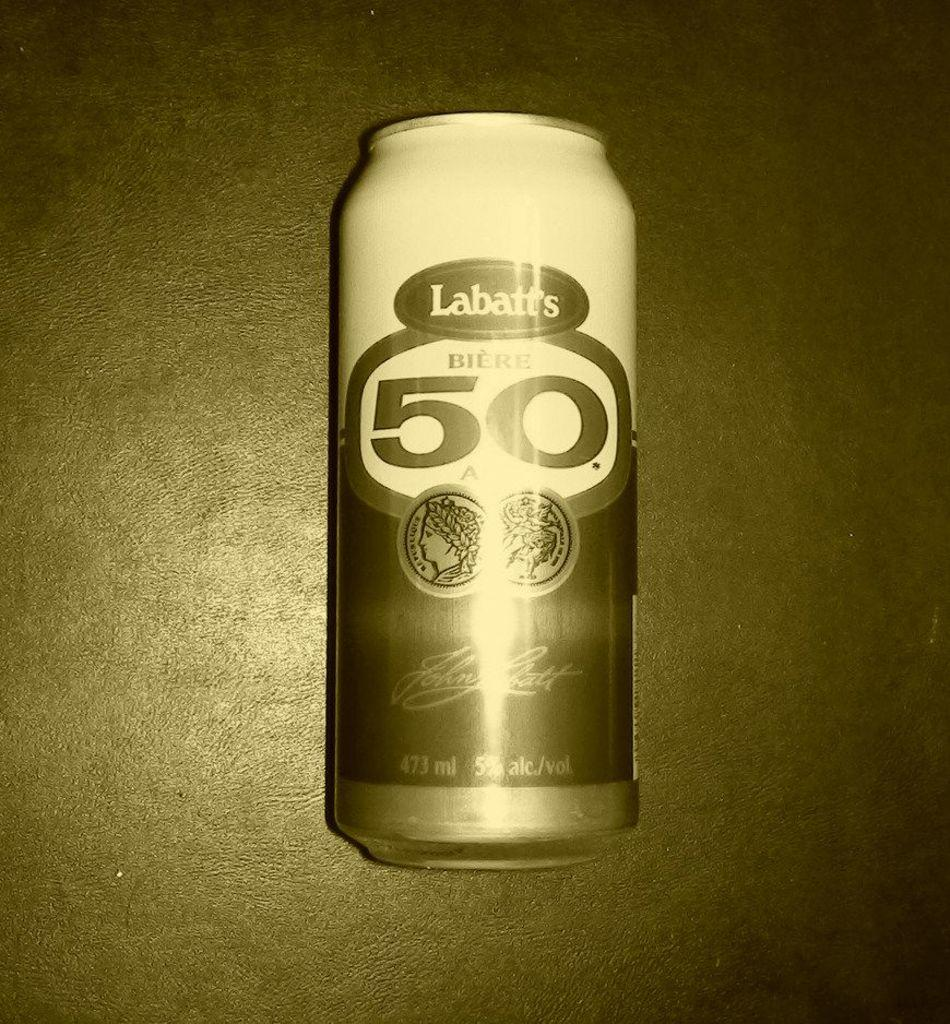<image>
Create a compact narrative representing the image presented. A can of Labatt's 50 beer which is 473 millilitres. 